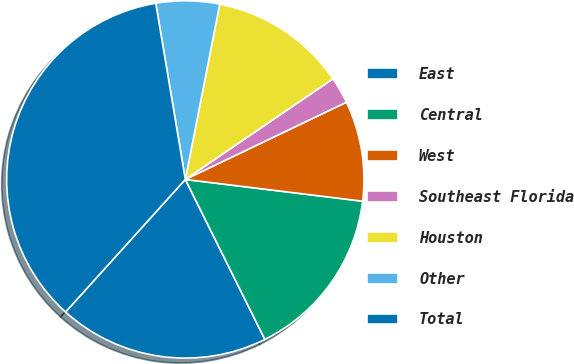Convert chart. <chart><loc_0><loc_0><loc_500><loc_500><pie_chart><fcel>East<fcel>Central<fcel>West<fcel>Southeast Florida<fcel>Houston<fcel>Other<fcel>Total<nl><fcel>19.04%<fcel>15.71%<fcel>9.06%<fcel>2.41%<fcel>12.39%<fcel>5.73%<fcel>35.66%<nl></chart> 